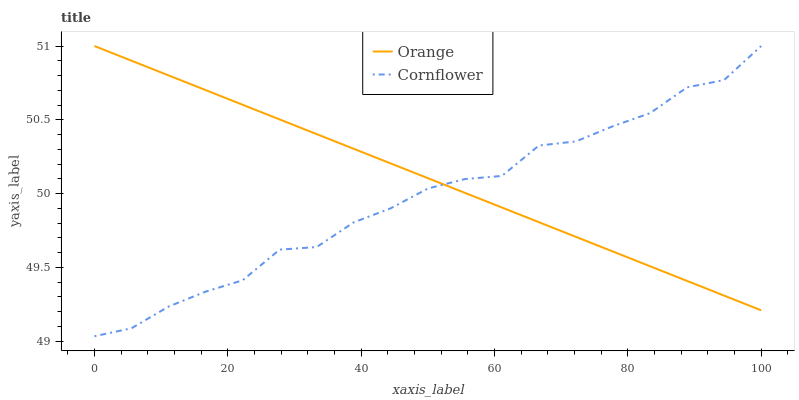Does Cornflower have the minimum area under the curve?
Answer yes or no. Yes. Does Orange have the maximum area under the curve?
Answer yes or no. Yes. Does Cornflower have the maximum area under the curve?
Answer yes or no. No. Is Orange the smoothest?
Answer yes or no. Yes. Is Cornflower the roughest?
Answer yes or no. Yes. Is Cornflower the smoothest?
Answer yes or no. No. Does Cornflower have the lowest value?
Answer yes or no. Yes. Does Cornflower have the highest value?
Answer yes or no. Yes. Does Orange intersect Cornflower?
Answer yes or no. Yes. Is Orange less than Cornflower?
Answer yes or no. No. Is Orange greater than Cornflower?
Answer yes or no. No. 